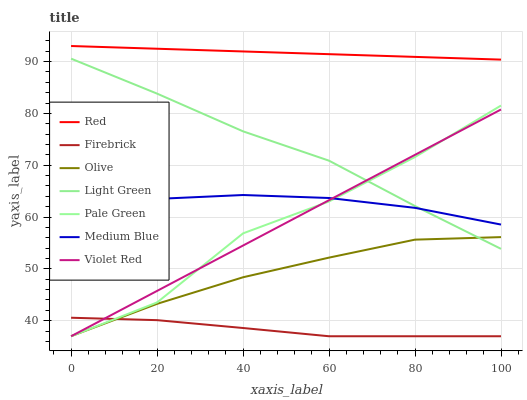Does Firebrick have the minimum area under the curve?
Answer yes or no. Yes. Does Red have the maximum area under the curve?
Answer yes or no. Yes. Does Medium Blue have the minimum area under the curve?
Answer yes or no. No. Does Medium Blue have the maximum area under the curve?
Answer yes or no. No. Is Violet Red the smoothest?
Answer yes or no. Yes. Is Pale Green the roughest?
Answer yes or no. Yes. Is Firebrick the smoothest?
Answer yes or no. No. Is Firebrick the roughest?
Answer yes or no. No. Does Violet Red have the lowest value?
Answer yes or no. Yes. Does Medium Blue have the lowest value?
Answer yes or no. No. Does Red have the highest value?
Answer yes or no. Yes. Does Medium Blue have the highest value?
Answer yes or no. No. Is Pale Green less than Red?
Answer yes or no. Yes. Is Medium Blue greater than Firebrick?
Answer yes or no. Yes. Does Olive intersect Pale Green?
Answer yes or no. Yes. Is Olive less than Pale Green?
Answer yes or no. No. Is Olive greater than Pale Green?
Answer yes or no. No. Does Pale Green intersect Red?
Answer yes or no. No. 